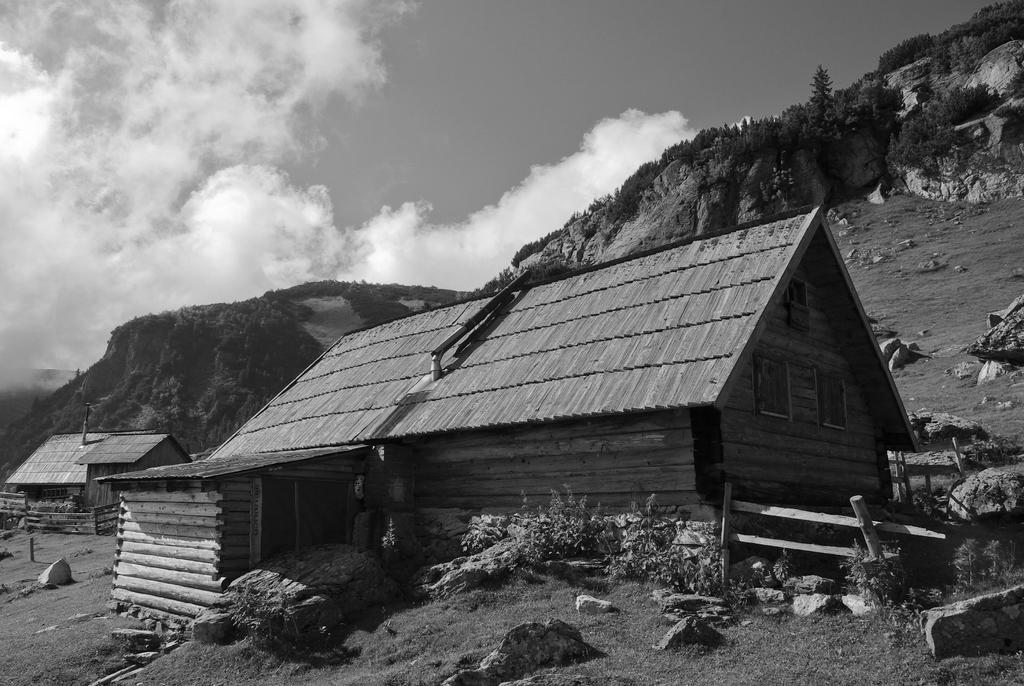What type of structures are present in the image? There are sheds in the image. What else can be seen in the image besides the sheds? There are plants in the image. What is visible in the background of the image? There are trees and rocks in the background of the image, as well as the sky. What type of collar can be seen on the trees in the image? There is no collar present on the trees in the image. 